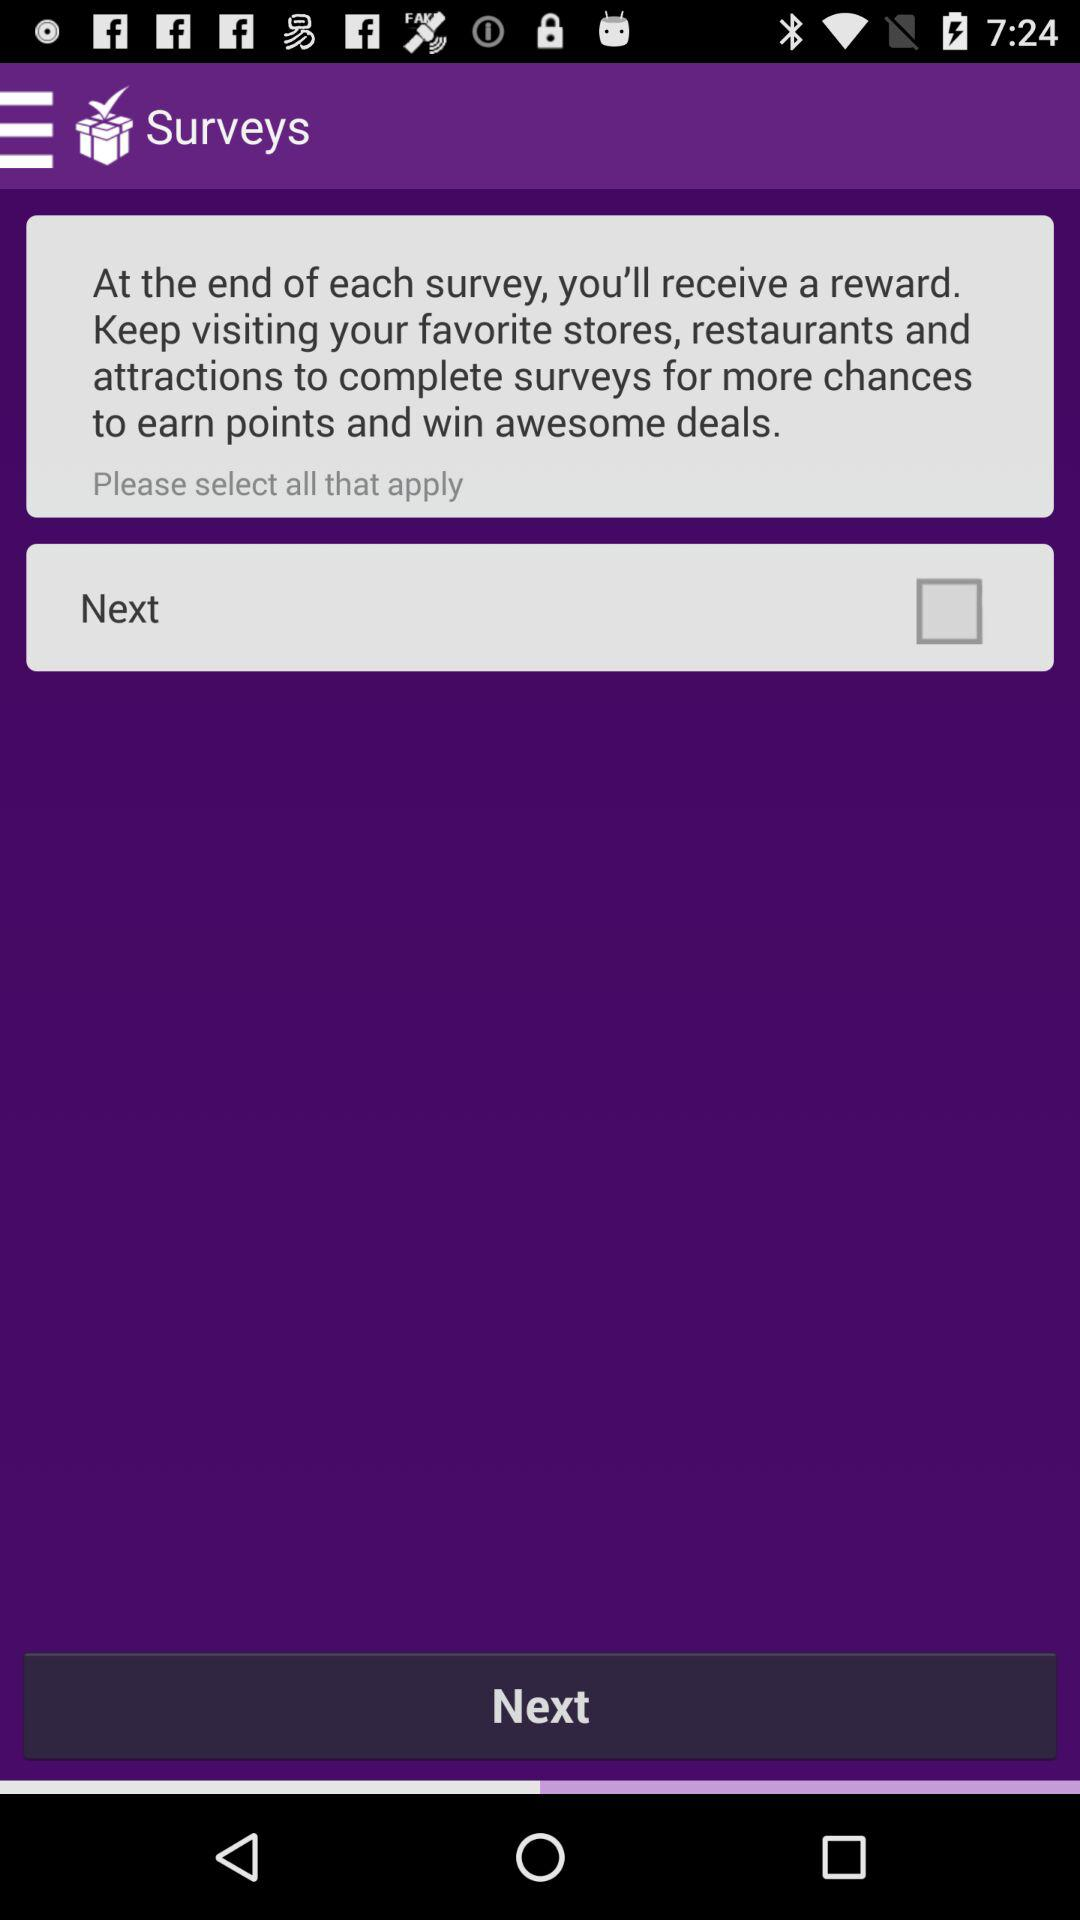What is the status of "Next"? The status is "off". 